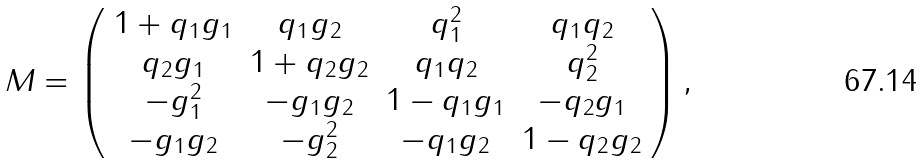Convert formula to latex. <formula><loc_0><loc_0><loc_500><loc_500>M = \left ( \begin{array} { c c c c } 1 + q _ { 1 } g _ { 1 } & q _ { 1 } g _ { 2 } & q _ { 1 } ^ { 2 } & q _ { 1 } q _ { 2 } \\ q _ { 2 } g _ { 1 } & 1 + q _ { 2 } g _ { 2 } & q _ { 1 } q _ { 2 } & q _ { 2 } ^ { 2 } \\ - g _ { 1 } ^ { 2 } & - g _ { 1 } g _ { 2 } & 1 - q _ { 1 } g _ { 1 } & - q _ { 2 } g _ { 1 } \\ - g _ { 1 } g _ { 2 } & - g _ { 2 } ^ { 2 } & - q _ { 1 } g _ { 2 } & 1 - q _ { 2 } g _ { 2 } \end{array} \right ) ,</formula> 